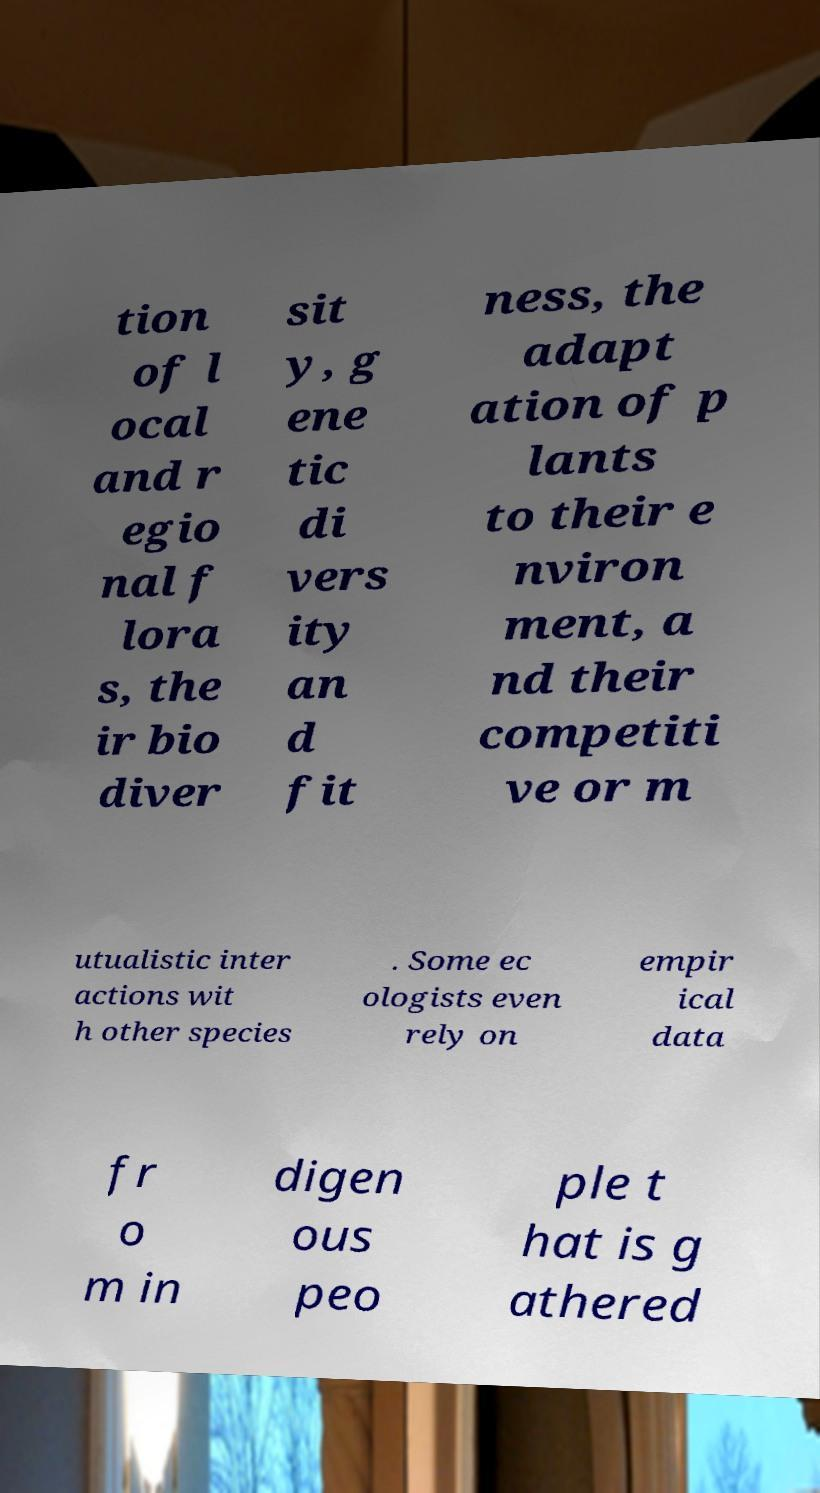Could you extract and type out the text from this image? tion of l ocal and r egio nal f lora s, the ir bio diver sit y, g ene tic di vers ity an d fit ness, the adapt ation of p lants to their e nviron ment, a nd their competiti ve or m utualistic inter actions wit h other species . Some ec ologists even rely on empir ical data fr o m in digen ous peo ple t hat is g athered 